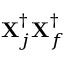<formula> <loc_0><loc_0><loc_500><loc_500>X _ { j } ^ { \dagger } X _ { f } ^ { \dagger }</formula> 